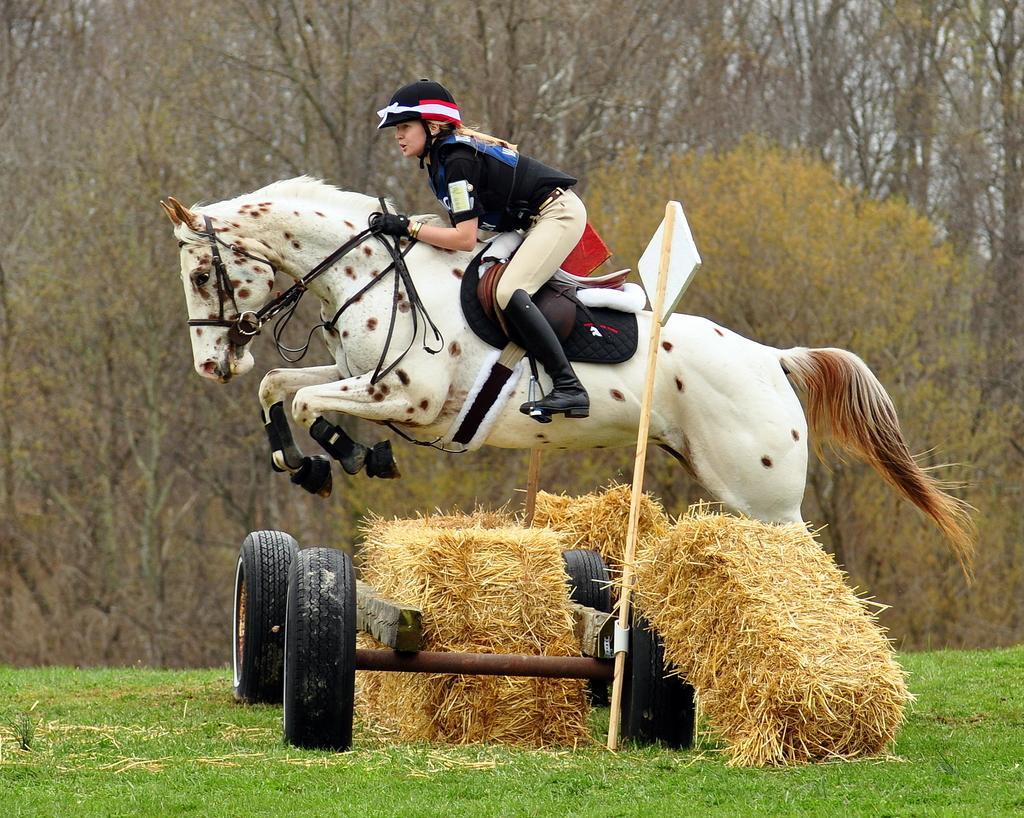In one or two sentences, can you explain what this image depicts? In the center of the image we can see one person riding a horse. And she is wearing a helmet. And we can see one vehicle, poles and dry grass. In the background we can see trees and grass. 